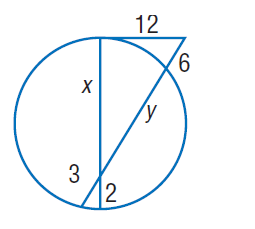Question: Find x. Round to the nearest tenth, if necessary.
Choices:
A. 2
B. 6
C. 12
D. 15
Answer with the letter. Answer: D Question: Find y. Round to the nearest tenth, if necessary.
Choices:
A. 2
B. 3
C. 6
D. 22.5
Answer with the letter. Answer: D 